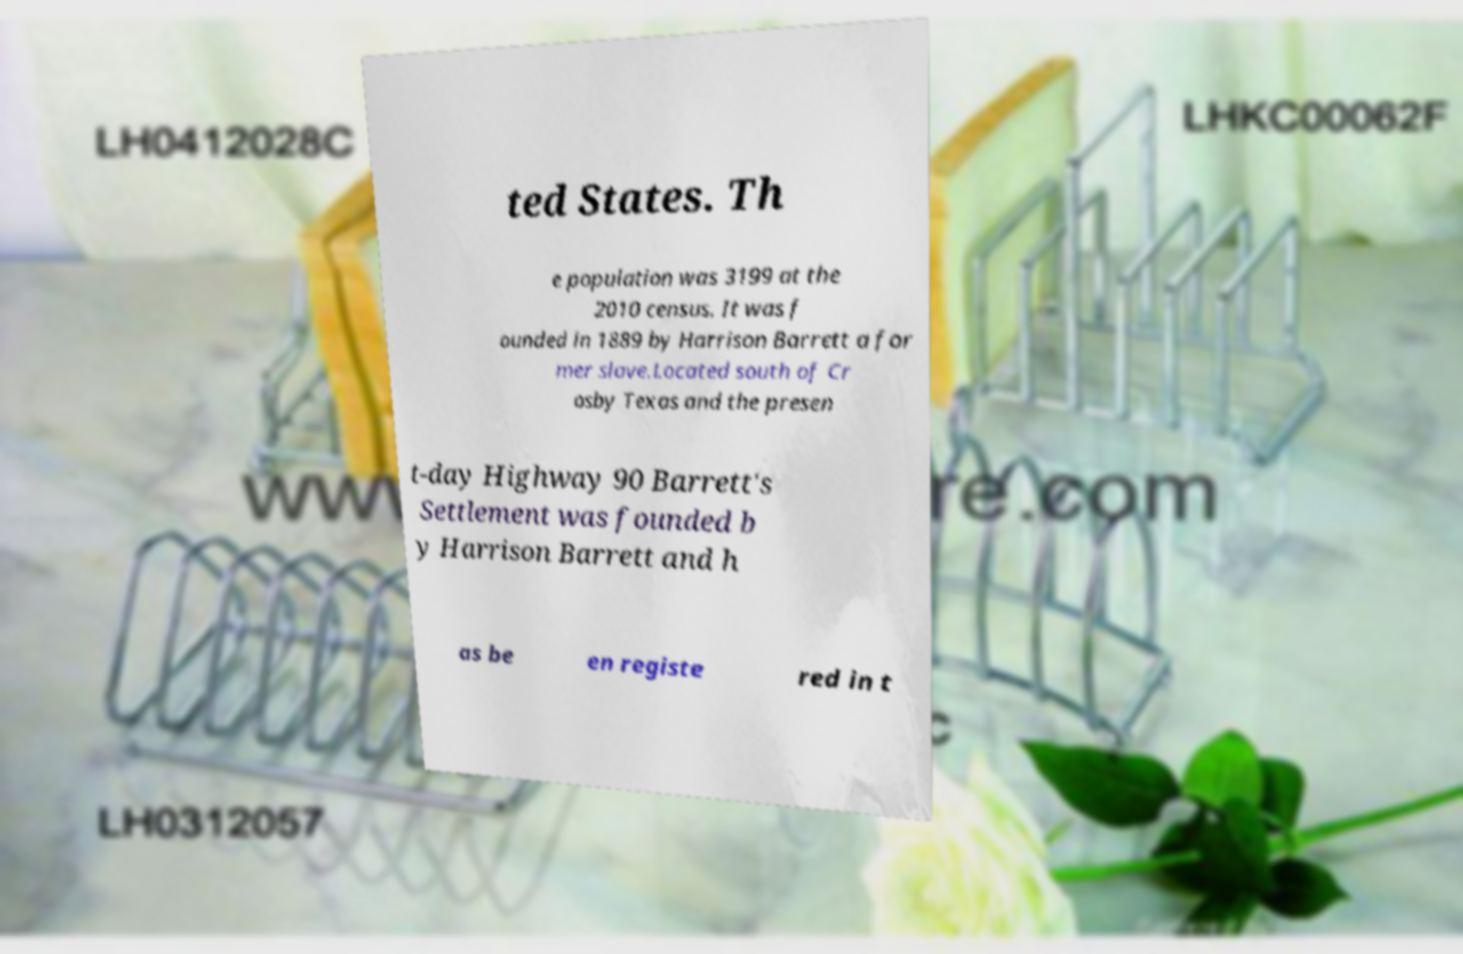Could you extract and type out the text from this image? ted States. Th e population was 3199 at the 2010 census. It was f ounded in 1889 by Harrison Barrett a for mer slave.Located south of Cr osby Texas and the presen t-day Highway 90 Barrett's Settlement was founded b y Harrison Barrett and h as be en registe red in t 